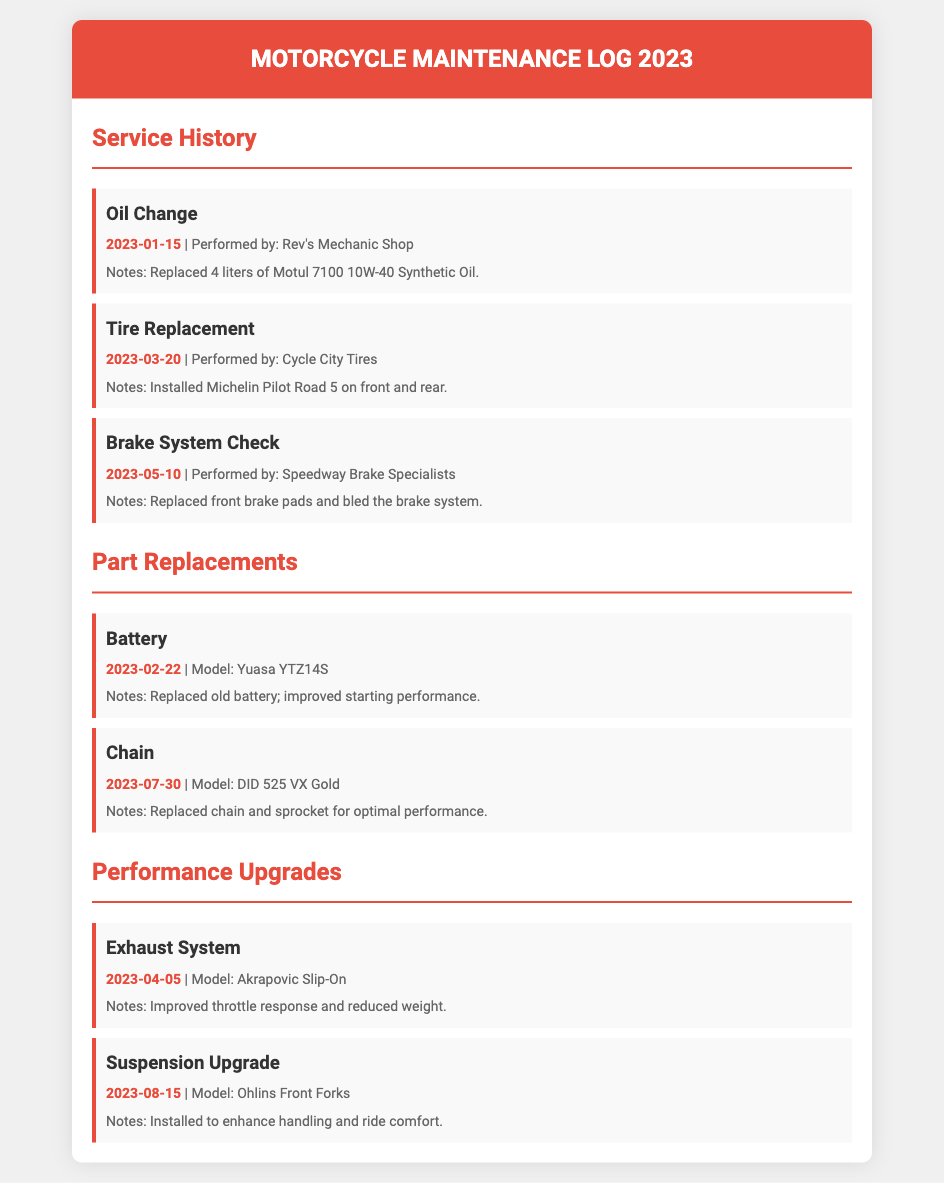What was the date of the oil change? The oil change was performed on January 15, 2023.
Answer: January 15, 2023 Who performed the brake system check? The brake system check was performed by Speedway Brake Specialists.
Answer: Speedway Brake Specialists What model was the replaced battery? The replaced battery model was Yuasa YTZ14S.
Answer: Yuasa YTZ14S What performance upgrade was made on April 5, 2023? The performance upgrade made on April 5, 2023, was an exhaust system installation.
Answer: Exhaust System How many liters of oil were replaced during the oil change? Four liters of oil were replaced during the oil change.
Answer: 4 liters What did the chain replacement improve? The chain replacement improved optimal performance.
Answer: Optimal performance When was the tire replacement done? The tire replacement was done on March 20, 2023.
Answer: March 20, 2023 Which upgrade was focused on enhancing ride comfort? The suspension upgrade was focused on enhancing ride comfort.
Answer: Suspension Upgrade 